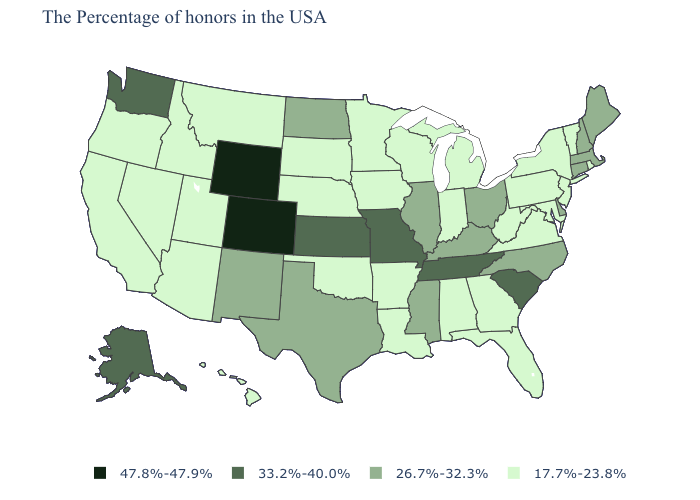Among the states that border Pennsylvania , which have the lowest value?
Write a very short answer. New York, New Jersey, Maryland, West Virginia. Does Wyoming have the lowest value in the West?
Short answer required. No. What is the lowest value in states that border Ohio?
Concise answer only. 17.7%-23.8%. What is the lowest value in the USA?
Give a very brief answer. 17.7%-23.8%. What is the value of California?
Concise answer only. 17.7%-23.8%. What is the lowest value in states that border Virginia?
Be succinct. 17.7%-23.8%. Name the states that have a value in the range 17.7%-23.8%?
Quick response, please. Rhode Island, Vermont, New York, New Jersey, Maryland, Pennsylvania, Virginia, West Virginia, Florida, Georgia, Michigan, Indiana, Alabama, Wisconsin, Louisiana, Arkansas, Minnesota, Iowa, Nebraska, Oklahoma, South Dakota, Utah, Montana, Arizona, Idaho, Nevada, California, Oregon, Hawaii. Which states have the highest value in the USA?
Quick response, please. Wyoming, Colorado. Name the states that have a value in the range 33.2%-40.0%?
Be succinct. South Carolina, Tennessee, Missouri, Kansas, Washington, Alaska. What is the value of California?
Quick response, please. 17.7%-23.8%. Does Mississippi have a higher value than North Dakota?
Concise answer only. No. What is the value of Florida?
Concise answer only. 17.7%-23.8%. Does Indiana have the highest value in the MidWest?
Short answer required. No. Which states hav the highest value in the West?
Answer briefly. Wyoming, Colorado. Does the map have missing data?
Write a very short answer. No. 